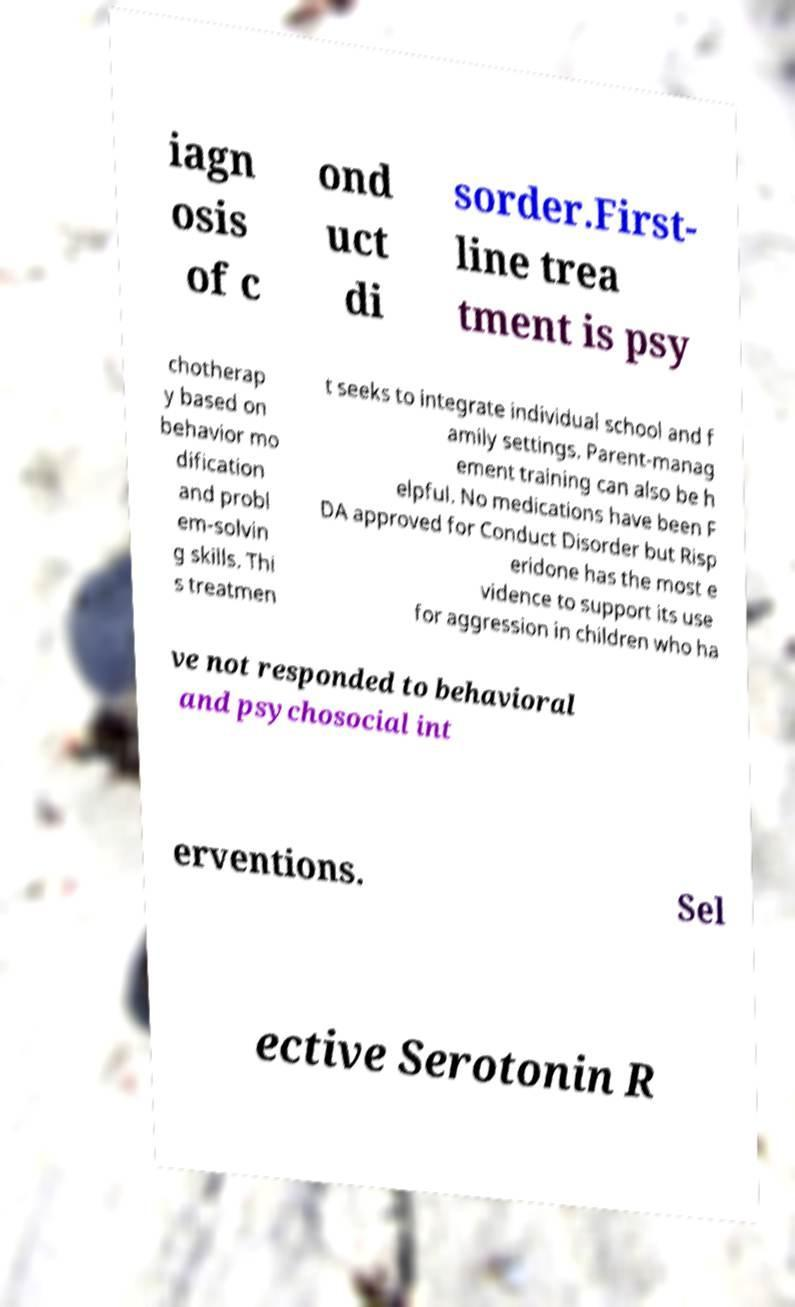What messages or text are displayed in this image? I need them in a readable, typed format. iagn osis of c ond uct di sorder.First- line trea tment is psy chotherap y based on behavior mo dification and probl em-solvin g skills. Thi s treatmen t seeks to integrate individual school and f amily settings. Parent-manag ement training can also be h elpful. No medications have been F DA approved for Conduct Disorder but Risp eridone has the most e vidence to support its use for aggression in children who ha ve not responded to behavioral and psychosocial int erventions. Sel ective Serotonin R 